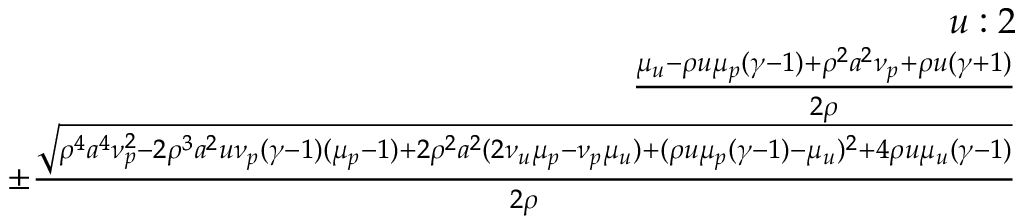<formula> <loc_0><loc_0><loc_500><loc_500>\begin{array} { r } { u \colon 2 } \\ { \frac { \mu _ { u } - \rho u \mu _ { p } ( \gamma - 1 ) + \rho ^ { 2 } a ^ { 2 } \nu _ { p } + \rho u ( \gamma + 1 ) } { 2 \rho } } \\ { \pm \frac { \sqrt { \rho ^ { 4 } a ^ { 4 } \nu _ { p } ^ { 2 } - 2 \rho ^ { 3 } a ^ { 2 } u \nu _ { p } ( \gamma - 1 ) ( \mu _ { p } - 1 ) + 2 \rho ^ { 2 } a ^ { 2 } ( 2 \nu _ { u } \mu _ { p } - \nu _ { p } \mu _ { u } ) + ( \rho u \mu _ { p } ( \gamma - 1 ) - \mu _ { u } ) ^ { 2 } + 4 \rho u \mu _ { u } ( \gamma - 1 ) } } { 2 \rho } } \end{array}</formula> 